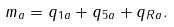Convert formula to latex. <formula><loc_0><loc_0><loc_500><loc_500>m _ { a } = q _ { 1 a } + q _ { 5 a } + q _ { R a } .</formula> 